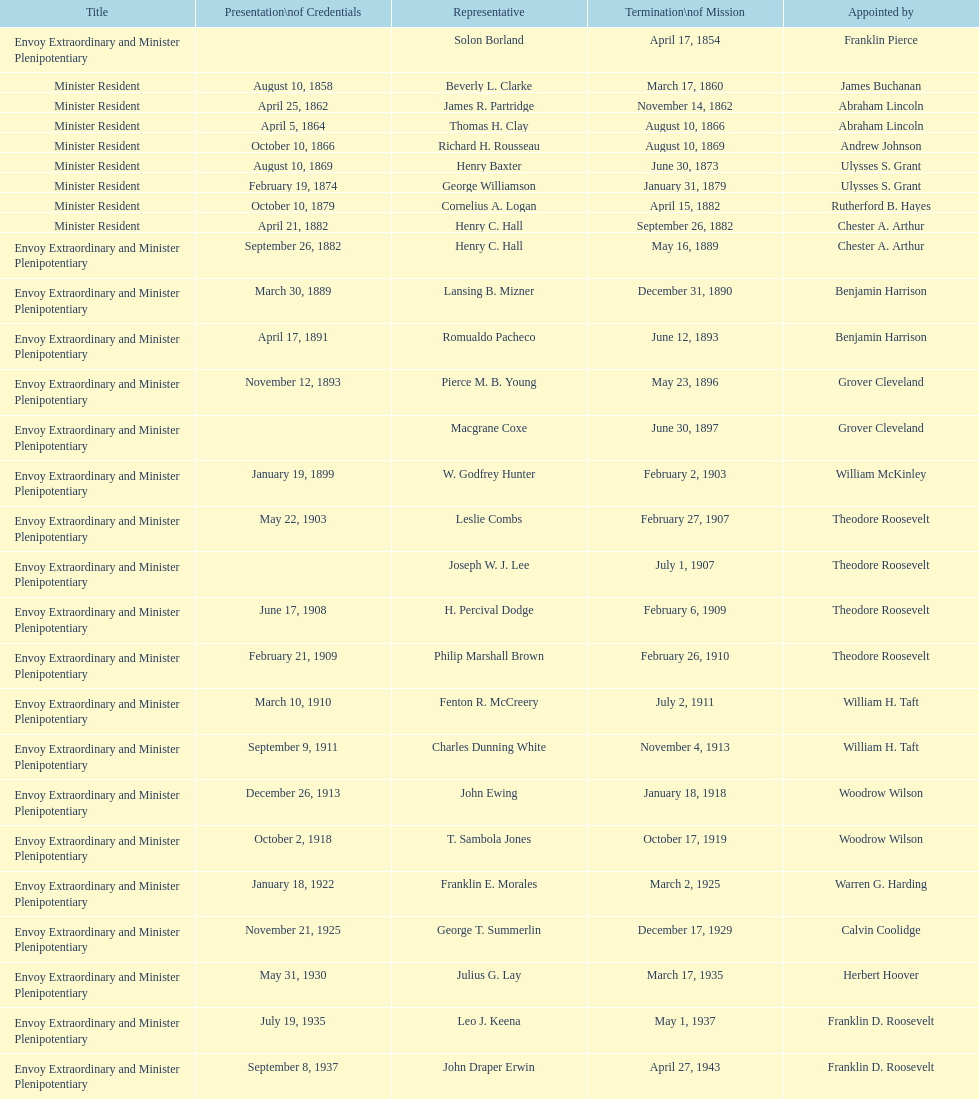Can you give me this table as a dict? {'header': ['Title', 'Presentation\\nof Credentials', 'Representative', 'Termination\\nof Mission', 'Appointed by'], 'rows': [['Envoy Extraordinary and Minister Plenipotentiary', '', 'Solon Borland', 'April 17, 1854', 'Franklin Pierce'], ['Minister Resident', 'August 10, 1858', 'Beverly L. Clarke', 'March 17, 1860', 'James Buchanan'], ['Minister Resident', 'April 25, 1862', 'James R. Partridge', 'November 14, 1862', 'Abraham Lincoln'], ['Minister Resident', 'April 5, 1864', 'Thomas H. Clay', 'August 10, 1866', 'Abraham Lincoln'], ['Minister Resident', 'October 10, 1866', 'Richard H. Rousseau', 'August 10, 1869', 'Andrew Johnson'], ['Minister Resident', 'August 10, 1869', 'Henry Baxter', 'June 30, 1873', 'Ulysses S. Grant'], ['Minister Resident', 'February 19, 1874', 'George Williamson', 'January 31, 1879', 'Ulysses S. Grant'], ['Minister Resident', 'October 10, 1879', 'Cornelius A. Logan', 'April 15, 1882', 'Rutherford B. Hayes'], ['Minister Resident', 'April 21, 1882', 'Henry C. Hall', 'September 26, 1882', 'Chester A. Arthur'], ['Envoy Extraordinary and Minister Plenipotentiary', 'September 26, 1882', 'Henry C. Hall', 'May 16, 1889', 'Chester A. Arthur'], ['Envoy Extraordinary and Minister Plenipotentiary', 'March 30, 1889', 'Lansing B. Mizner', 'December 31, 1890', 'Benjamin Harrison'], ['Envoy Extraordinary and Minister Plenipotentiary', 'April 17, 1891', 'Romualdo Pacheco', 'June 12, 1893', 'Benjamin Harrison'], ['Envoy Extraordinary and Minister Plenipotentiary', 'November 12, 1893', 'Pierce M. B. Young', 'May 23, 1896', 'Grover Cleveland'], ['Envoy Extraordinary and Minister Plenipotentiary', '', 'Macgrane Coxe', 'June 30, 1897', 'Grover Cleveland'], ['Envoy Extraordinary and Minister Plenipotentiary', 'January 19, 1899', 'W. Godfrey Hunter', 'February 2, 1903', 'William McKinley'], ['Envoy Extraordinary and Minister Plenipotentiary', 'May 22, 1903', 'Leslie Combs', 'February 27, 1907', 'Theodore Roosevelt'], ['Envoy Extraordinary and Minister Plenipotentiary', '', 'Joseph W. J. Lee', 'July 1, 1907', 'Theodore Roosevelt'], ['Envoy Extraordinary and Minister Plenipotentiary', 'June 17, 1908', 'H. Percival Dodge', 'February 6, 1909', 'Theodore Roosevelt'], ['Envoy Extraordinary and Minister Plenipotentiary', 'February 21, 1909', 'Philip Marshall Brown', 'February 26, 1910', 'Theodore Roosevelt'], ['Envoy Extraordinary and Minister Plenipotentiary', 'March 10, 1910', 'Fenton R. McCreery', 'July 2, 1911', 'William H. Taft'], ['Envoy Extraordinary and Minister Plenipotentiary', 'September 9, 1911', 'Charles Dunning White', 'November 4, 1913', 'William H. Taft'], ['Envoy Extraordinary and Minister Plenipotentiary', 'December 26, 1913', 'John Ewing', 'January 18, 1918', 'Woodrow Wilson'], ['Envoy Extraordinary and Minister Plenipotentiary', 'October 2, 1918', 'T. Sambola Jones', 'October 17, 1919', 'Woodrow Wilson'], ['Envoy Extraordinary and Minister Plenipotentiary', 'January 18, 1922', 'Franklin E. Morales', 'March 2, 1925', 'Warren G. Harding'], ['Envoy Extraordinary and Minister Plenipotentiary', 'November 21, 1925', 'George T. Summerlin', 'December 17, 1929', 'Calvin Coolidge'], ['Envoy Extraordinary and Minister Plenipotentiary', 'May 31, 1930', 'Julius G. Lay', 'March 17, 1935', 'Herbert Hoover'], ['Envoy Extraordinary and Minister Plenipotentiary', 'July 19, 1935', 'Leo J. Keena', 'May 1, 1937', 'Franklin D. Roosevelt'], ['Envoy Extraordinary and Minister Plenipotentiary', 'September 8, 1937', 'John Draper Erwin', 'April 27, 1943', 'Franklin D. Roosevelt'], ['Ambassador Extraordinary and Plenipotentiary', 'April 27, 1943', 'John Draper Erwin', 'April 16, 1947', 'Franklin D. Roosevelt'], ['Ambassador Extraordinary and Plenipotentiary', 'June 23, 1947', 'Paul C. Daniels', 'October 30, 1947', 'Harry S. Truman'], ['Ambassador Extraordinary and Plenipotentiary', 'May 15, 1948', 'Herbert S. Bursley', 'December 12, 1950', 'Harry S. Truman'], ['Ambassador Extraordinary and Plenipotentiary', 'March 14, 1951', 'John Draper Erwin', 'February 28, 1954', 'Harry S. Truman'], ['Ambassador Extraordinary and Plenipotentiary', 'March 5, 1954', 'Whiting Willauer', 'March 24, 1958', 'Dwight D. Eisenhower'], ['Ambassador Extraordinary and Plenipotentiary', 'April 30, 1958', 'Robert Newbegin', 'August 3, 1960', 'Dwight D. Eisenhower'], ['Ambassador Extraordinary and Plenipotentiary', 'November 3, 1960', 'Charles R. Burrows', 'June 28, 1965', 'Dwight D. Eisenhower'], ['Ambassador Extraordinary and Plenipotentiary', 'July 12, 1965', 'Joseph J. Jova', 'June 21, 1969', 'Lyndon B. Johnson'], ['Ambassador Extraordinary and Plenipotentiary', 'November 5, 1969', 'Hewson A. Ryan', 'May 30, 1973', 'Richard Nixon'], ['Ambassador Extraordinary and Plenipotentiary', 'June 15, 1973', 'Phillip V. Sanchez', 'July 17, 1976', 'Richard Nixon'], ['Ambassador Extraordinary and Plenipotentiary', 'October 27, 1976', 'Ralph E. Becker', 'August 1, 1977', 'Gerald Ford'], ['Ambassador Extraordinary and Plenipotentiary', 'October 27, 1977', 'Mari-Luci Jaramillo', 'September 19, 1980', 'Jimmy Carter'], ['Ambassador Extraordinary and Plenipotentiary', 'October 10, 1980', 'Jack R. Binns', 'October 31, 1981', 'Jimmy Carter'], ['Ambassador Extraordinary and Plenipotentiary', 'November 11, 1981', 'John D. Negroponte', 'May 30, 1985', 'Ronald Reagan'], ['Ambassador Extraordinary and Plenipotentiary', 'August 22, 1985', 'John Arthur Ferch', 'July 9, 1986', 'Ronald Reagan'], ['Ambassador Extraordinary and Plenipotentiary', 'November 4, 1986', 'Everett Ellis Briggs', 'June 15, 1989', 'Ronald Reagan'], ['Ambassador Extraordinary and Plenipotentiary', 'January 29, 1990', 'Cresencio S. Arcos, Jr.', 'July 1, 1993', 'George H. W. Bush'], ['Ambassador Extraordinary and Plenipotentiary', 'July 21, 1993', 'William Thornton Pryce', 'August 15, 1996', 'Bill Clinton'], ['Ambassador Extraordinary and Plenipotentiary', 'August 29, 1996', 'James F. Creagan', 'July 20, 1999', 'Bill Clinton'], ['Ambassador Extraordinary and Plenipotentiary', 'August 25, 1999', 'Frank Almaguer', 'September 5, 2002', 'Bill Clinton'], ['Ambassador Extraordinary and Plenipotentiary', 'October 8, 2002', 'Larry Leon Palmer', 'May 7, 2005', 'George W. Bush'], ['Ambassador Extraordinary and Plenipotentiary', 'November 8, 2005', 'Charles A. Ford', 'ca. April 2008', 'George W. Bush'], ['Ambassador Extraordinary and Plenipotentiary', 'September 19, 2008', 'Hugo Llorens', 'ca. July 2011', 'George W. Bush'], ['Ambassador Extraordinary and Plenipotentiary', 'July 26, 2011', 'Lisa Kubiske', 'Incumbent', 'Barack Obama']]} How many representatives were appointed by theodore roosevelt? 4. 